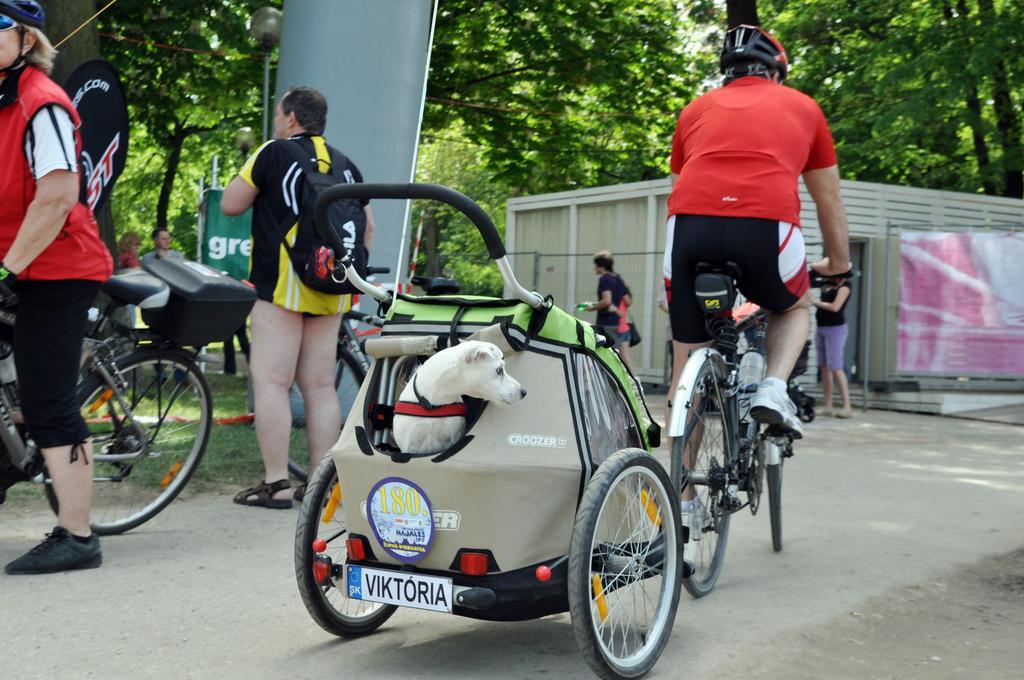Describe this image in one or two sentences. In this picture we can see a group of people where a person riding a bicycle on the road, dog, bags, shed, box, banners and in the background we can see trees. 